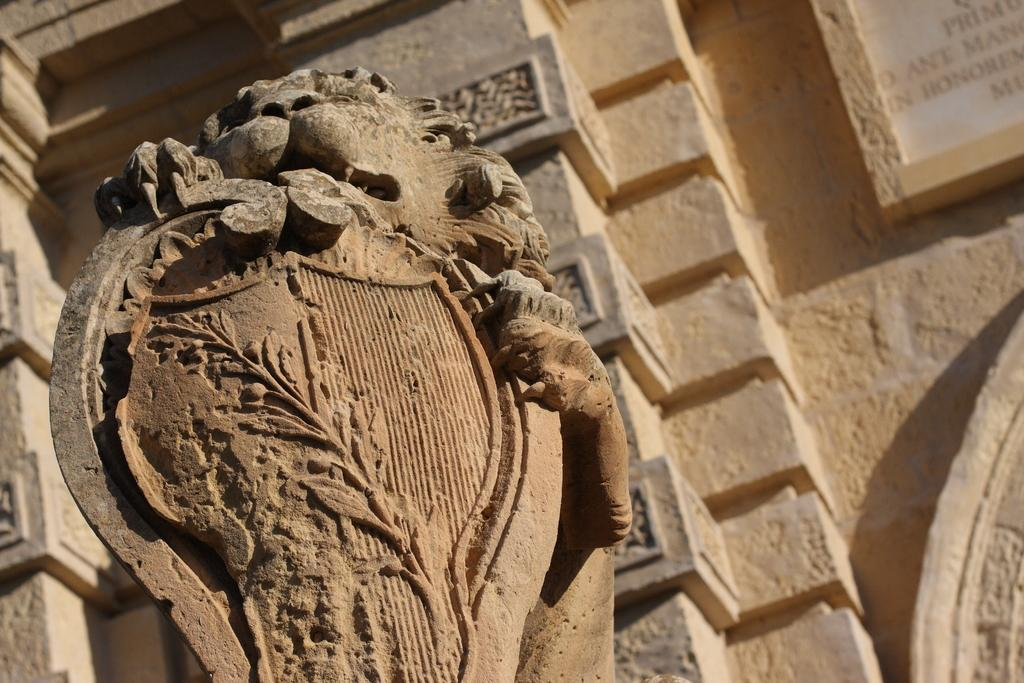What type of object is the main subject of the image? There is a statue of an animal in the image. Can you describe the statue's location in the image? The statue is likely the main focus of the image. What else can be seen in the background of the image? There is a board on the wall in the background of the image. What type of statement is written on the honey in the image? There is no honey present in the image, and therefore no statement can be written on it. 